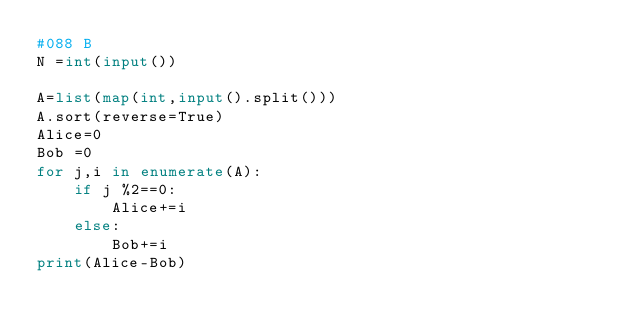<code> <loc_0><loc_0><loc_500><loc_500><_Python_>#088 B
N =int(input())

A=list(map(int,input().split()))
A.sort(reverse=True)
Alice=0
Bob =0
for j,i in enumerate(A):
    if j %2==0:
        Alice+=i
    else:
        Bob+=i
print(Alice-Bob)</code> 